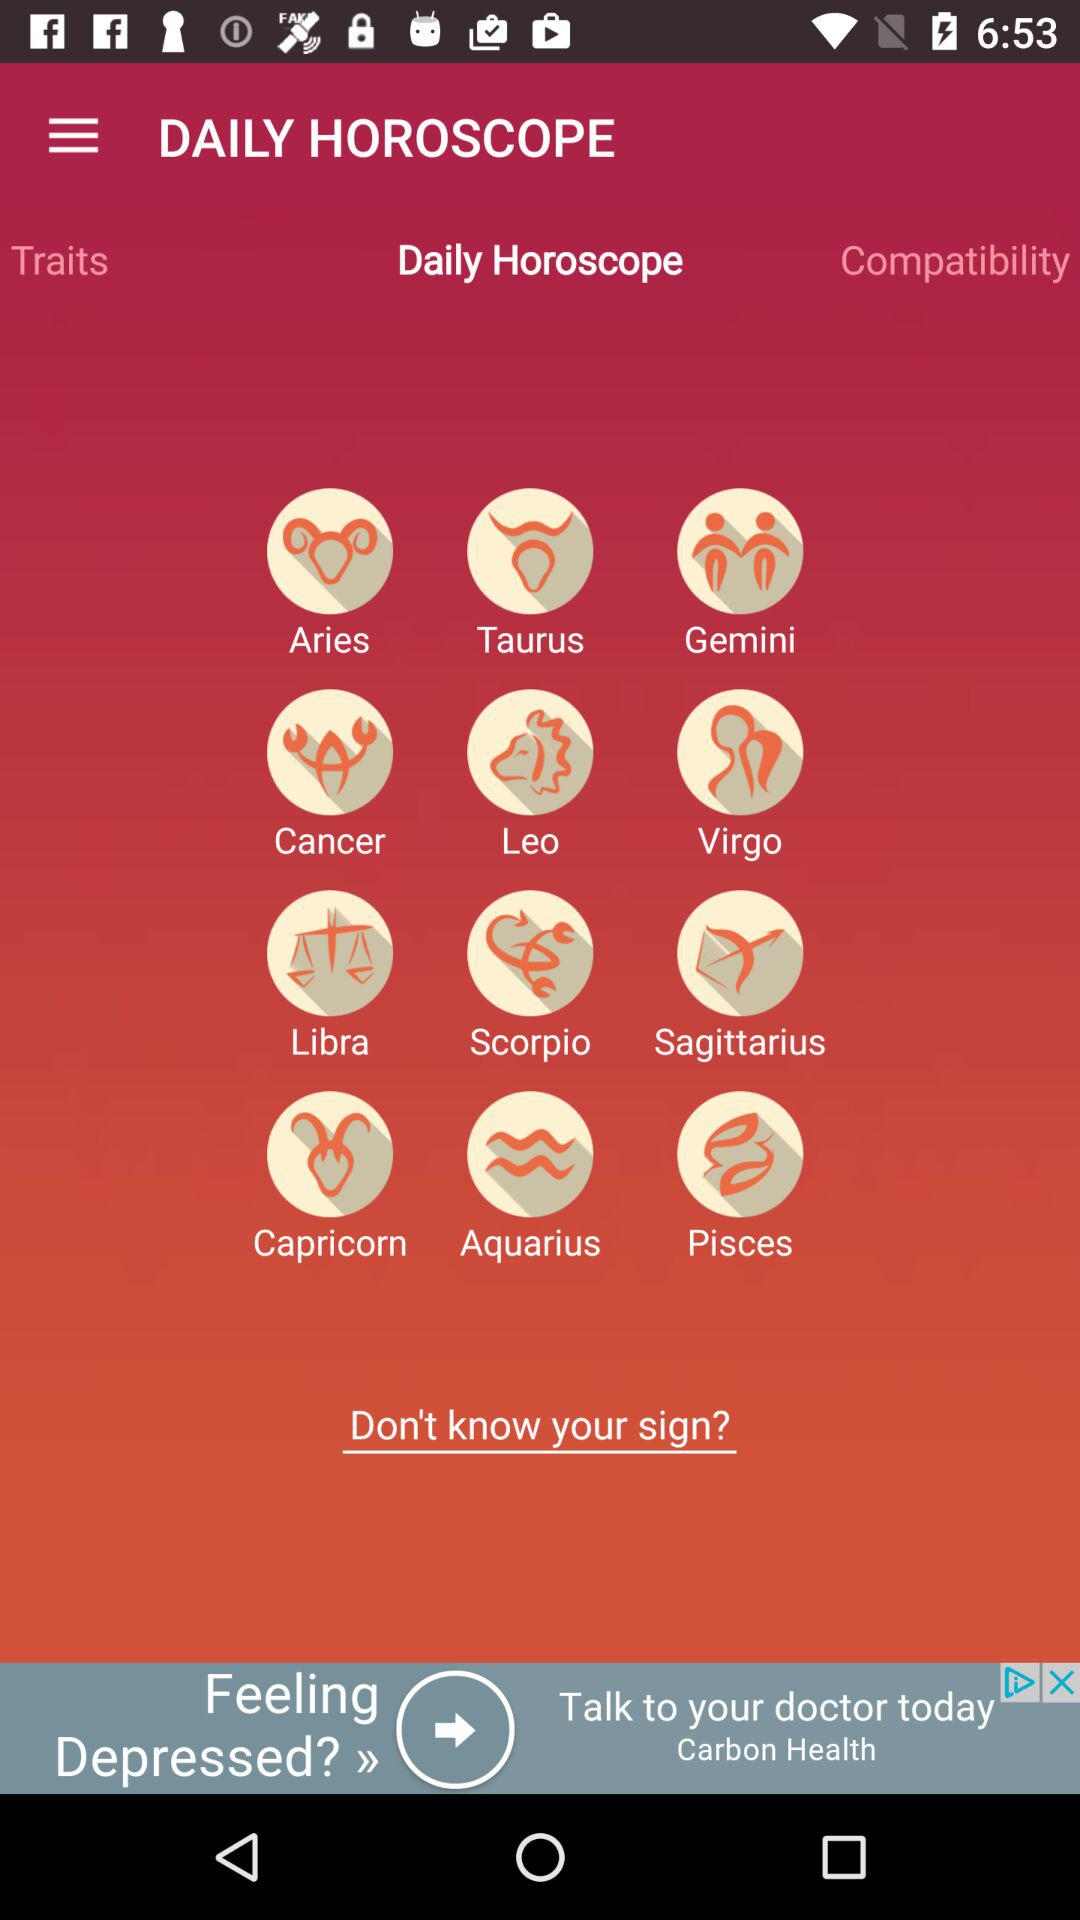How many signs are there in the Zodiac?
Answer the question using a single word or phrase. 12 